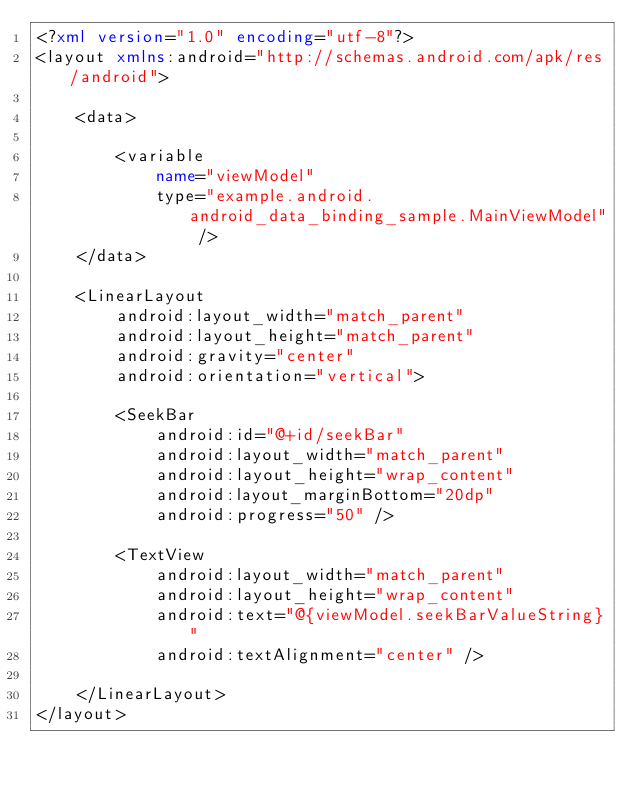<code> <loc_0><loc_0><loc_500><loc_500><_XML_><?xml version="1.0" encoding="utf-8"?>
<layout xmlns:android="http://schemas.android.com/apk/res/android">

    <data>

        <variable
            name="viewModel"
            type="example.android.android_data_binding_sample.MainViewModel" />
    </data>

    <LinearLayout
        android:layout_width="match_parent"
        android:layout_height="match_parent"
        android:gravity="center"
        android:orientation="vertical">

        <SeekBar
            android:id="@+id/seekBar"
            android:layout_width="match_parent"
            android:layout_height="wrap_content"
            android:layout_marginBottom="20dp"
            android:progress="50" />

        <TextView
            android:layout_width="match_parent"
            android:layout_height="wrap_content"
            android:text="@{viewModel.seekBarValueString}"
            android:textAlignment="center" />

    </LinearLayout>
</layout>
</code> 